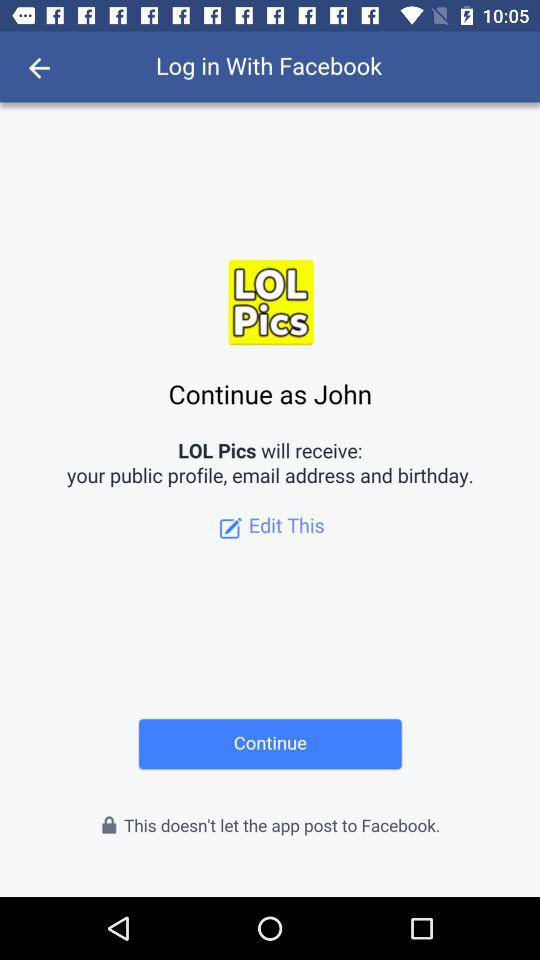Through which application is the person logging in? The person is logging in through the Facebook application. 